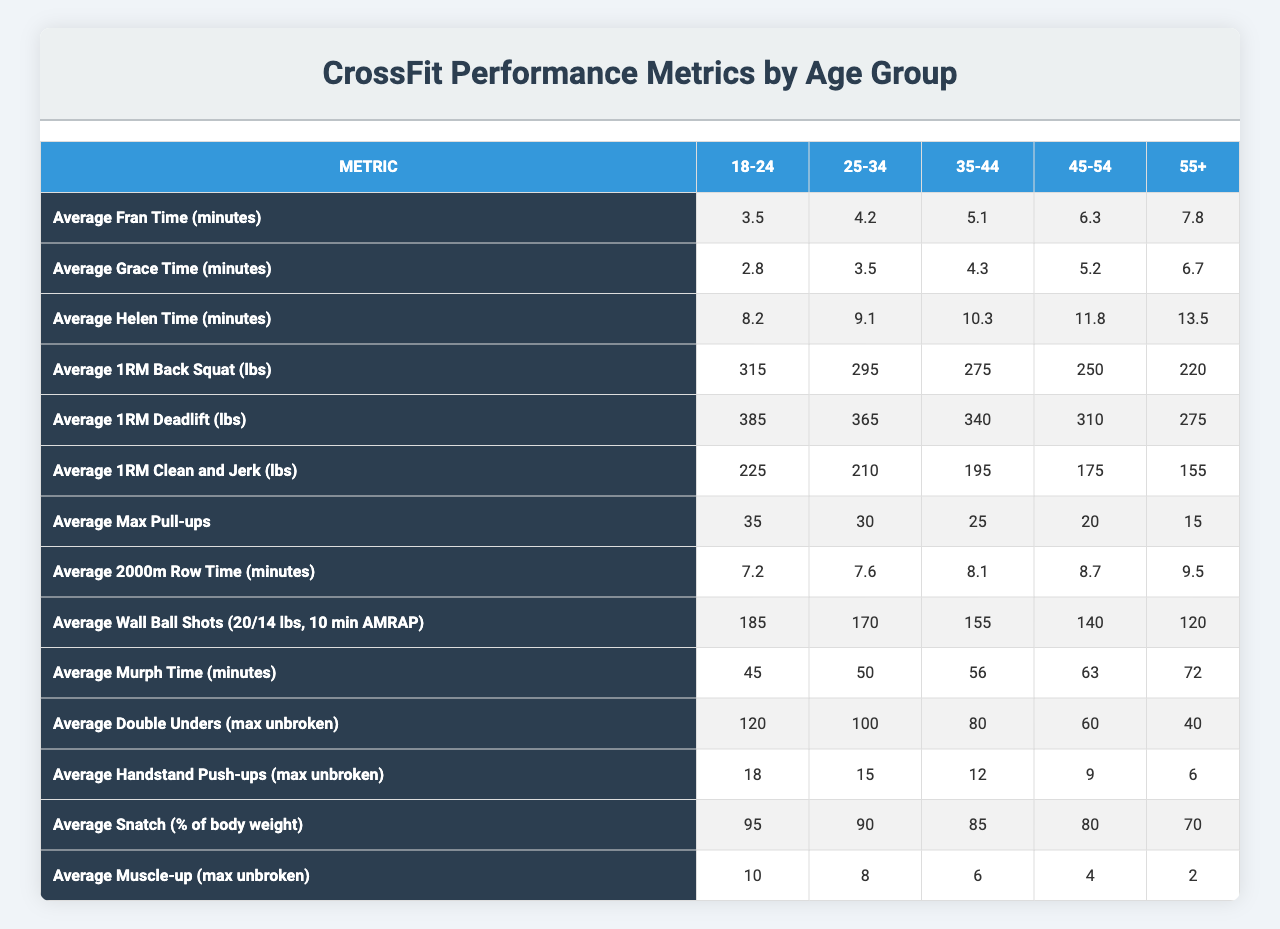What is the average Fran time for the 35-44 age group? The table shows the average Fran time for the 35-44 age group as 5.1 minutes.
Answer: 5.1 minutes Which age group has the highest average 1RM Deadlift? According to the table, the 18-24 age group has the highest average 1RM Deadlift, which is 385 lbs.
Answer: 385 lbs What is the difference in average Wall Ball Shots between the 18-24 and 55+ age groups? The average Wall Ball Shots for the 18-24 age group is 185, and for the 55+ group, it is 120. The difference is 185 - 120 = 65.
Answer: 65 Is the average Murph time for the 25-34 age group less than that of the 45-54 age group? The average Murph time for the 25-34 age group is 50 minutes, while for the 45-54 age group, it is 63 minutes. Since 50 is less than 63, the statement is true.
Answer: Yes What is the average 1RM Clean and Jerk for the 55+ age group compared to the 25-34 age group, and what is the percentage decrease? The average 1RM Clean and Jerk for the 55+ group is 155 lbs and for the 25-34 group is 210 lbs. The decrease is 210 - 155 = 55 lbs. The percentage decrease is (55 / 210) x 100 = about 26.19%.
Answer: 26.19% What is the maximum number of unbroken double unders for the 35-44 age group? The table indicates that the maximum number of unbroken double unders for the 35-44 age group is 80.
Answer: 80 Which age group has a higher average 1RM Back Squat, 35-44 or 45-54? The average 1RM Back Squat for the 35-44 age group is 275 lbs, while for the 45-54 age group, it is 250 lbs. Since 275 is greater than 250, the 35-44 age group has a higher average.
Answer: 35-44 age group How many more average Handstand Push-ups can the 25-34 age group do compared to the 55+ age group? The average Handstand Push-ups for the 25-34 age group is 15, and for the 55+ group, it is 6. The difference is 15 - 6 = 9.
Answer: 9 Which age group has the lowest average max pull-ups? The table shows that the 55+ age group has the lowest average max pull-ups, with a count of 15.
Answer: 15 What is the average Helen time for the 25-34 age group expressed as a percentage of the average Helen time for the 18-24 age group? The average Helen time for the 25-34 age group is 9.1 minutes, and for the 18-24 age group, it is 8.2 minutes. The percentage is (9.1 / 8.2) x 100 = about 110.98%.
Answer: 110.98% 